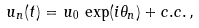<formula> <loc_0><loc_0><loc_500><loc_500>u _ { n } ( t ) = u _ { 0 } \, \exp ( i \theta _ { n } ) + c . c . \, ,</formula> 